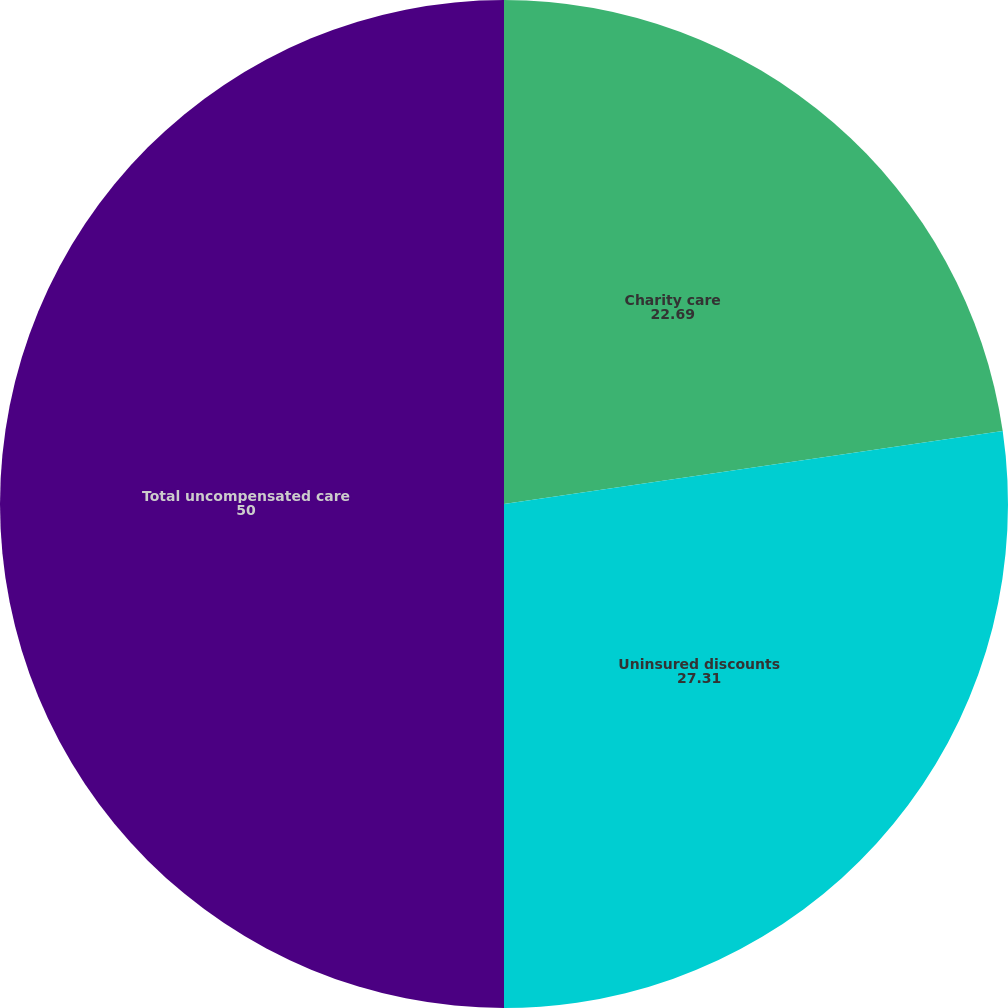<chart> <loc_0><loc_0><loc_500><loc_500><pie_chart><fcel>Charity care<fcel>Uninsured discounts<fcel>Total uncompensated care<nl><fcel>22.69%<fcel>27.31%<fcel>50.0%<nl></chart> 